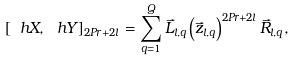<formula> <loc_0><loc_0><loc_500><loc_500>[ \ h X , \ h Y ] _ { 2 P r + 2 l } = \sum _ { q = 1 } ^ { Q } \vec { L } _ { l , q } \left ( \vec { z } _ { l , q } \right ) ^ { 2 P r + 2 l } \vec { R } _ { l , q } ,</formula> 